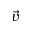<formula> <loc_0><loc_0><loc_500><loc_500>\ V e c { v }</formula> 